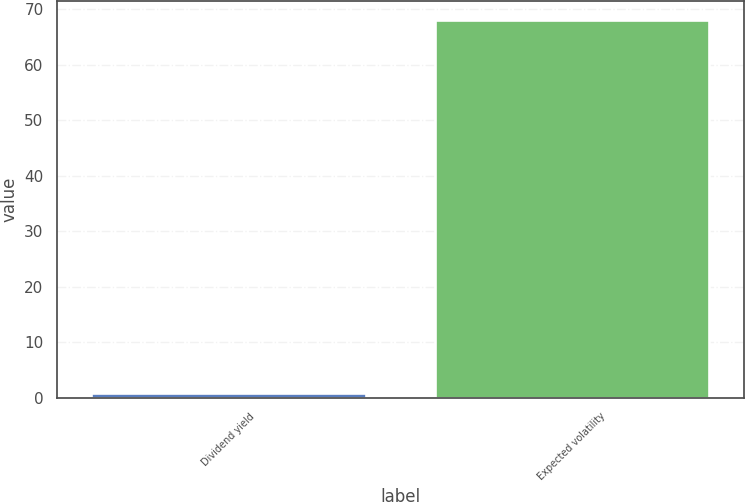Convert chart to OTSL. <chart><loc_0><loc_0><loc_500><loc_500><bar_chart><fcel>Dividend yield<fcel>Expected volatility<nl><fcel>0.97<fcel>68<nl></chart> 